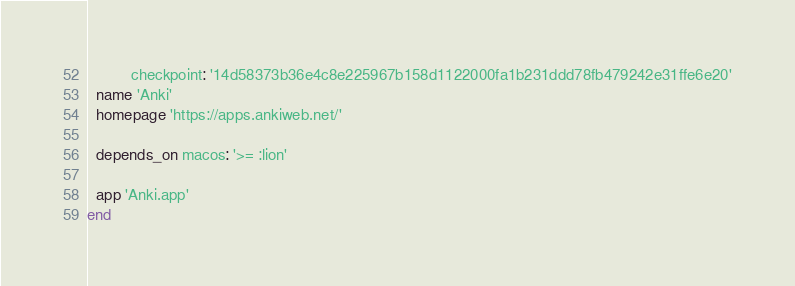Convert code to text. <code><loc_0><loc_0><loc_500><loc_500><_Ruby_>          checkpoint: '14d58373b36e4c8e225967b158d1122000fa1b231ddd78fb479242e31ffe6e20'
  name 'Anki'
  homepage 'https://apps.ankiweb.net/'

  depends_on macos: '>= :lion'

  app 'Anki.app'
end
</code> 